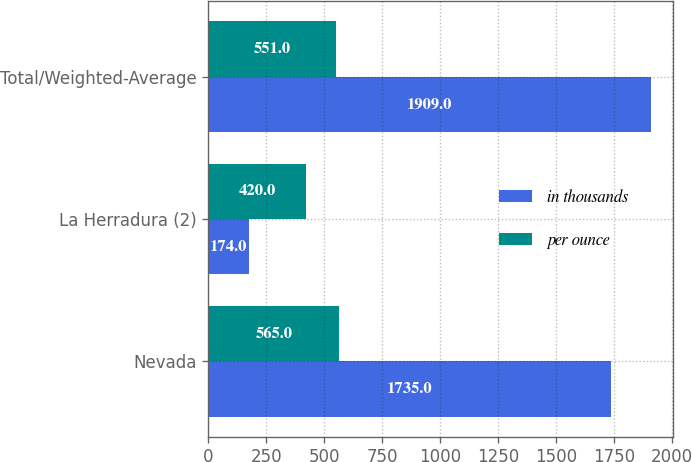<chart> <loc_0><loc_0><loc_500><loc_500><stacked_bar_chart><ecel><fcel>Nevada<fcel>La Herradura (2)<fcel>Total/Weighted-Average<nl><fcel>in thousands<fcel>1735<fcel>174<fcel>1909<nl><fcel>per ounce<fcel>565<fcel>420<fcel>551<nl></chart> 